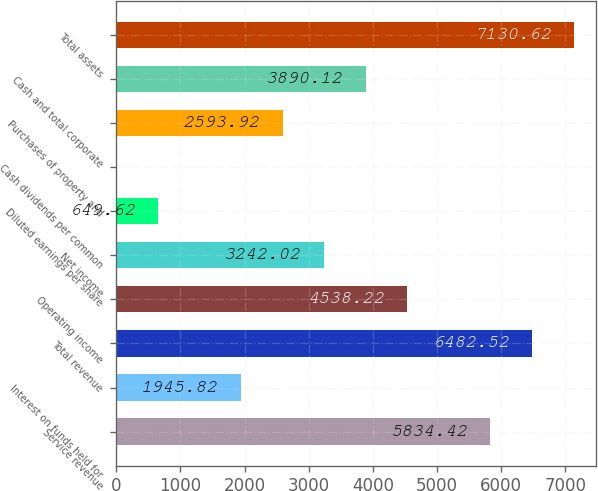Convert chart. <chart><loc_0><loc_0><loc_500><loc_500><bar_chart><fcel>Service revenue<fcel>Interest on funds held for<fcel>Total revenue<fcel>Operating income<fcel>Net income<fcel>Diluted earnings per share<fcel>Cash dividends per common<fcel>Purchases of property and<fcel>Cash and total corporate<fcel>Total assets<nl><fcel>5834.42<fcel>1945.82<fcel>6482.52<fcel>4538.22<fcel>3242.02<fcel>649.62<fcel>1.52<fcel>2593.92<fcel>3890.12<fcel>7130.62<nl></chart> 